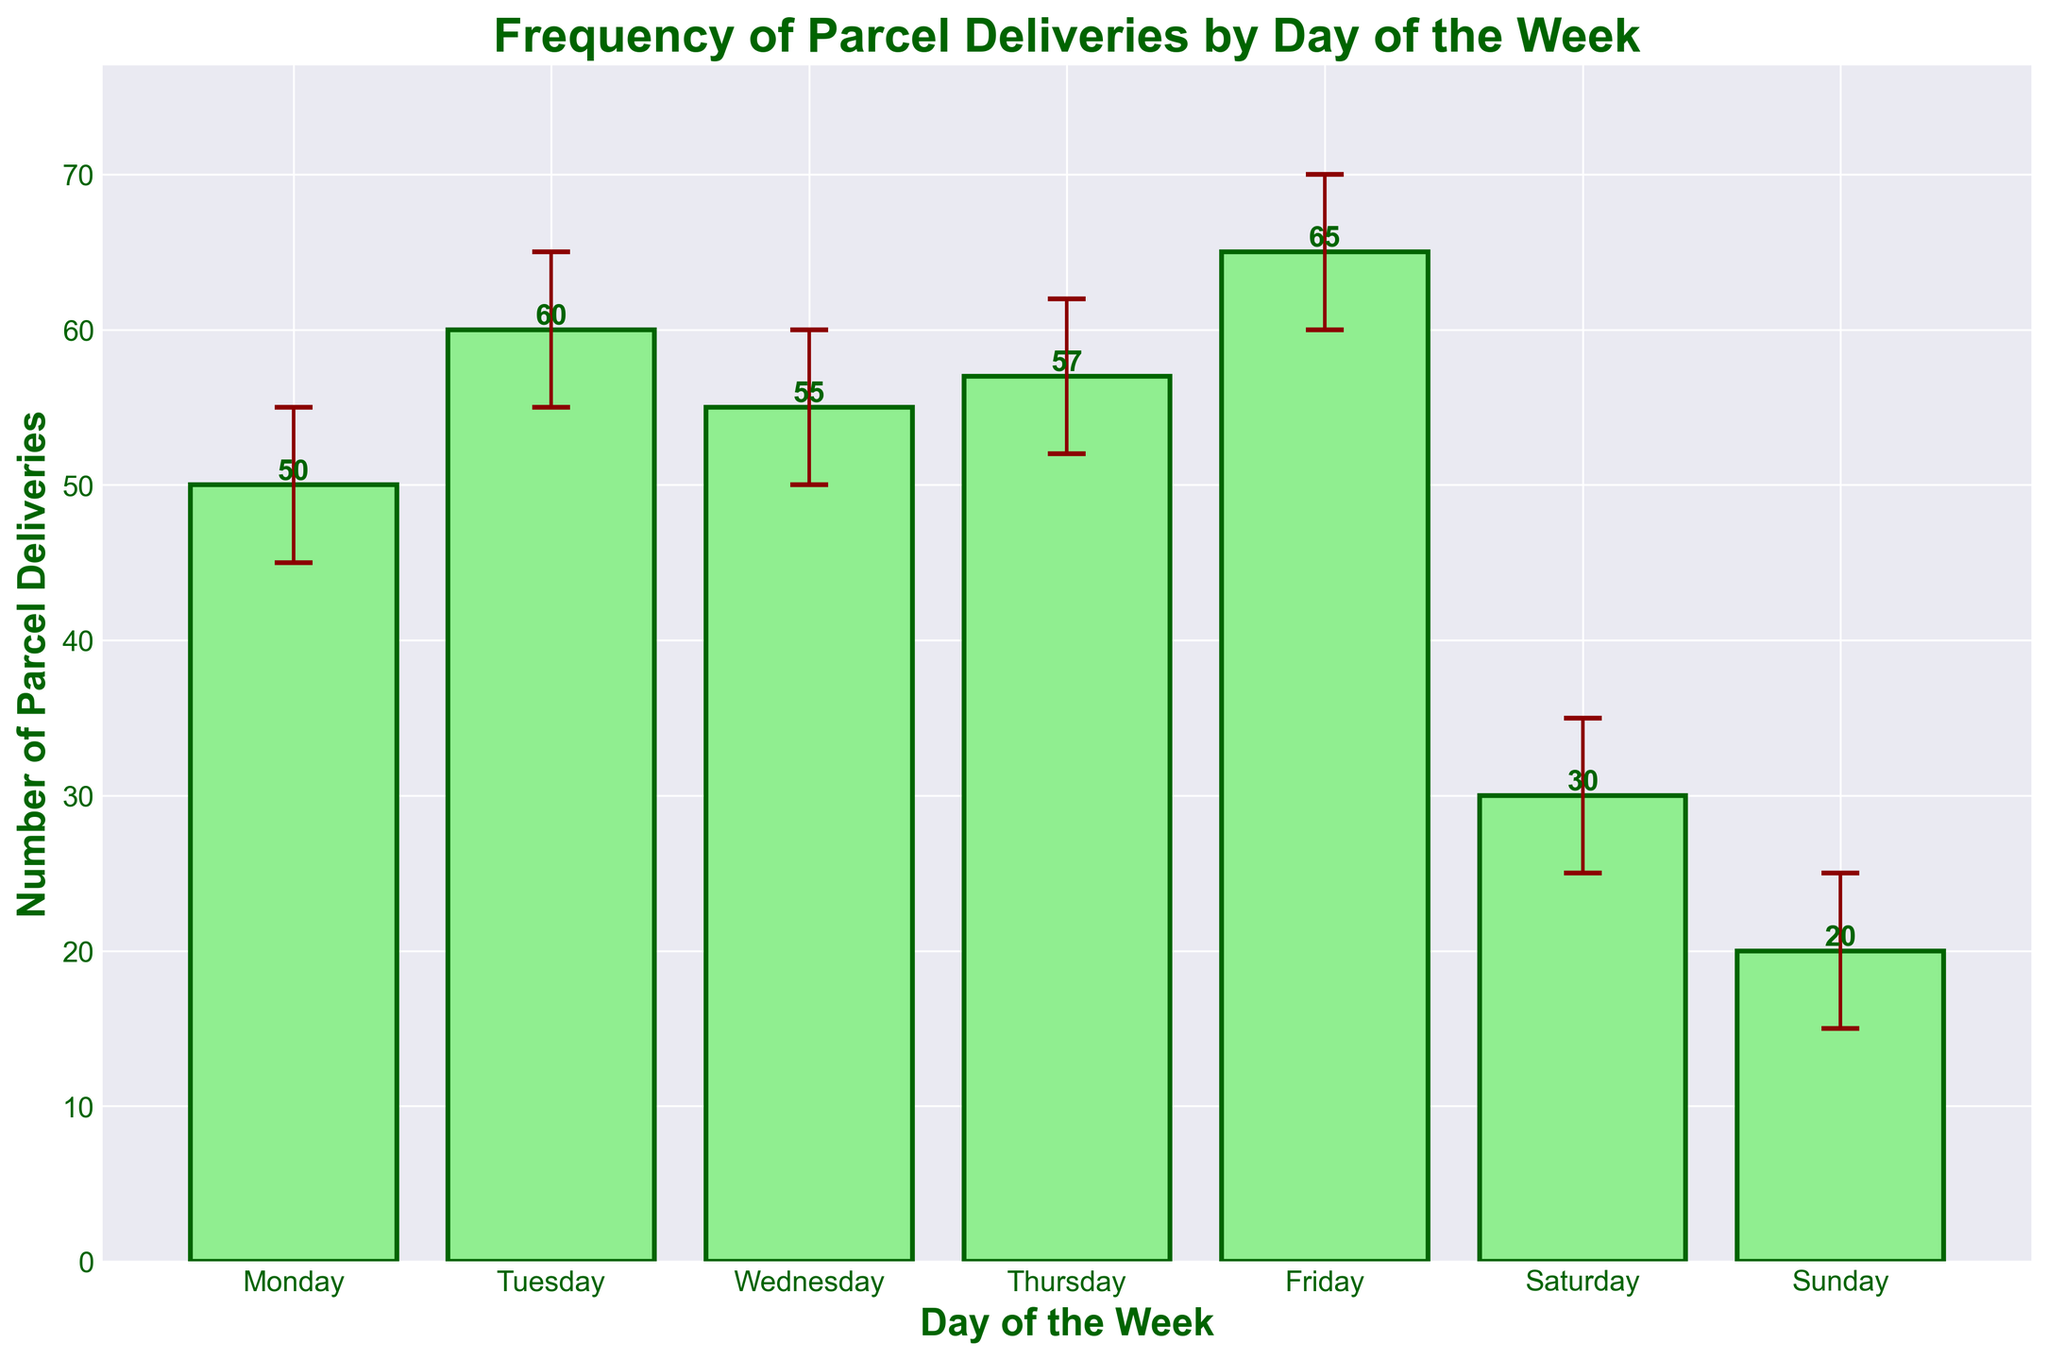What is the title of the chart? The title of the chart is usually found at the top center of the figure. It summarizes the main focus or subject of the data being presented.
Answer: Frequency of Parcel Deliveries by Day of the Week How many days are depicted in the bar chart? The number of days can be counted by looking at the x-axis, where each bar represents a different day of the week.
Answer: 7 What is the average number of parcel deliveries on Tuesday? To find the average number of deliveries for Tuesday, refer to the height of the bar labeled "Tuesday" on this chart.
Answer: 60 Which day has the highest average number of parcel deliveries? Look at the heights of all the bars and identify the tallest one, which shows the day with the highest average parcel deliveries.
Answer: Friday What is the range of parcel deliveries on Sunday? To determine the range, subtract the minimum error value for Sunday from the maximum error value.
Answer: 25 - 15 = 10 How does the number of average parcel deliveries on Wednesday compare to that on Thursday? Compare the heights of the bars for Wednesday and Thursday directly to see which one is taller or if they are similar.
Answer: Wednesday (55) has fewer deliveries than Thursday (57) What is the average number of parcel deliveries on the weekends (Saturday and Sunday)? Sum the average deliveries for both days and divide by the number of days to get the weekend average.
Answer: (30 + 20) / 2 = 25 What are the error bars representing on each bar? The error bars, shown as vertical lines with caps, indicate the variability or uncertainty in the average number of parcel deliveries for each day. The lower end represents the Error_Low and the upper end the Error_High values.
Answer: Variability or uncertainty Which day has the greatest variability in parcel deliveries based on the error bars? Find the day where the length of the error bars (difference between Error_High and Error_Low) is the largest.
Answer: Friday What is the total sum of the average parcel deliveries from Monday to Friday? Sum up the average deliveries from Monday to Friday to find the total.
Answer: 50 + 60 + 55 + 57 + 65 = 287 